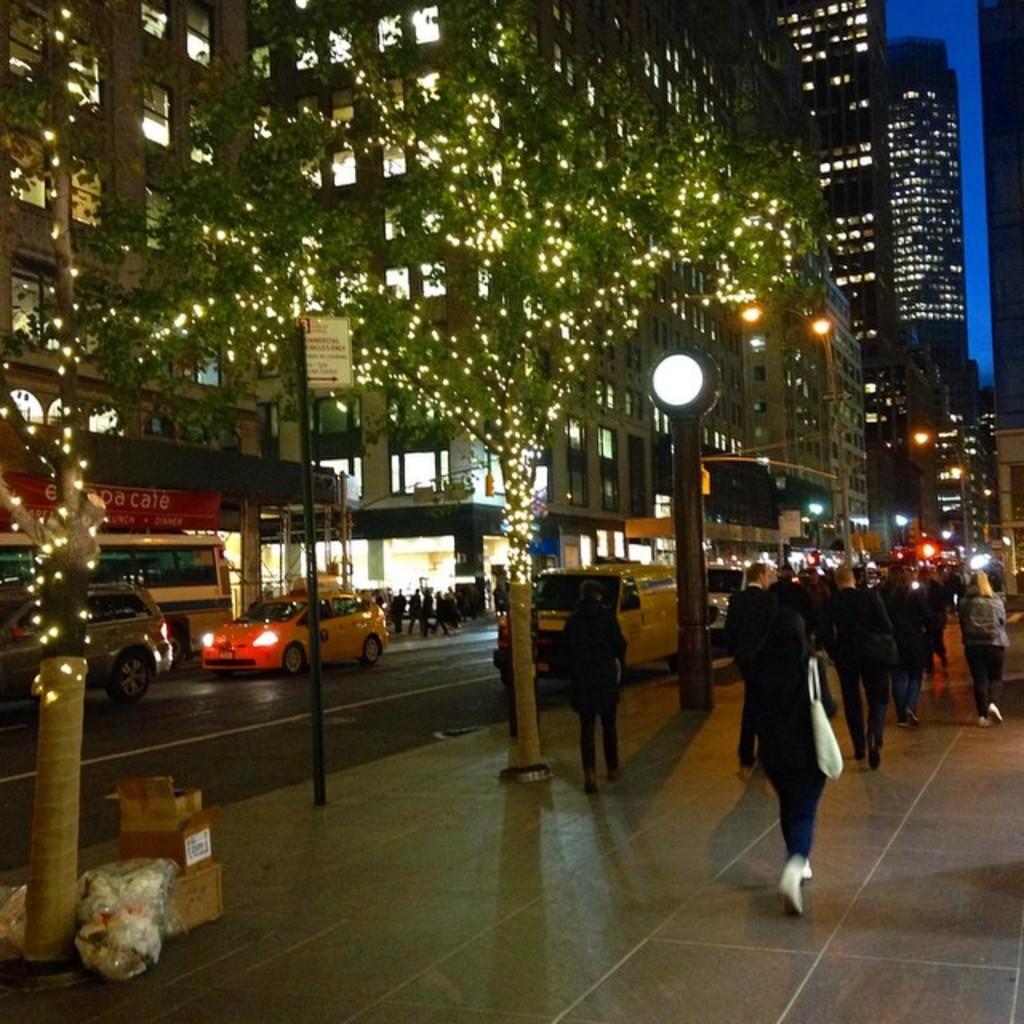Could you give a brief overview of what you see in this image? In this image I can see building , on top of building I can see lights , on which I can see vehicles and persons, beside the road I can see footpath on which persons waking, poles, boxes kept on it. 